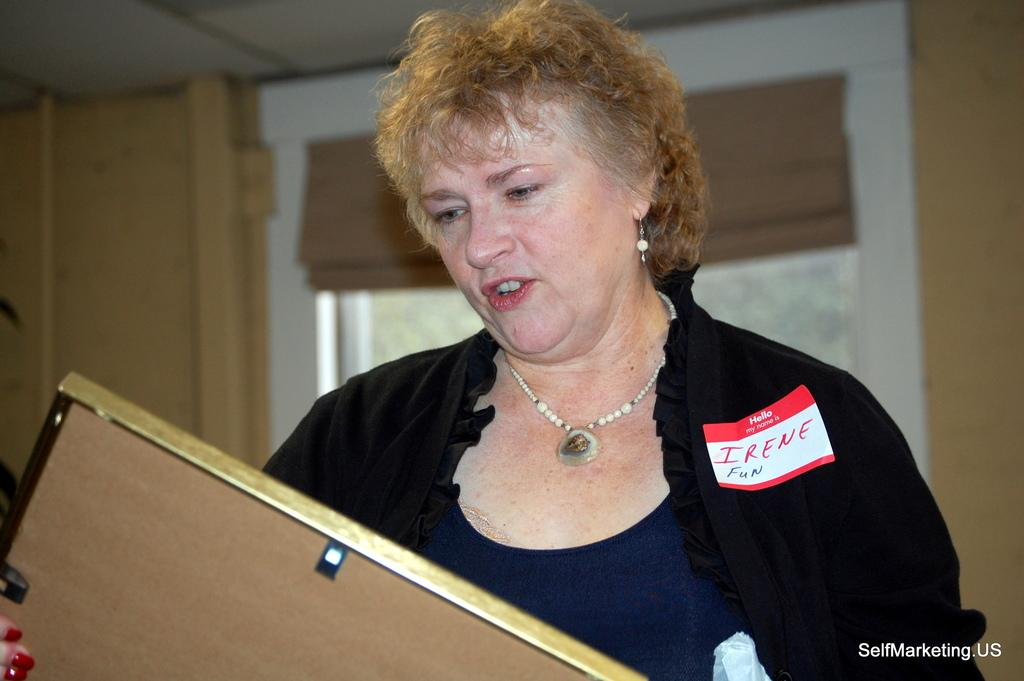What is the woman holding in the image? The woman is holding a photo frame in the image. What can be seen through the window in the image? The question cannot be answered definitively from the provided facts, as the contents of the window are not mentioned. What type of structure is visible in the image? There is a wall and a roof visible in the image, which suggests a building or room. What type of polish is being applied to the playground in the image? There is no playground or polish present in the image. What thrilling activity is taking place in the image? The question cannot be answered definitively from the provided facts, as the image does not depict any specific activity or event. 